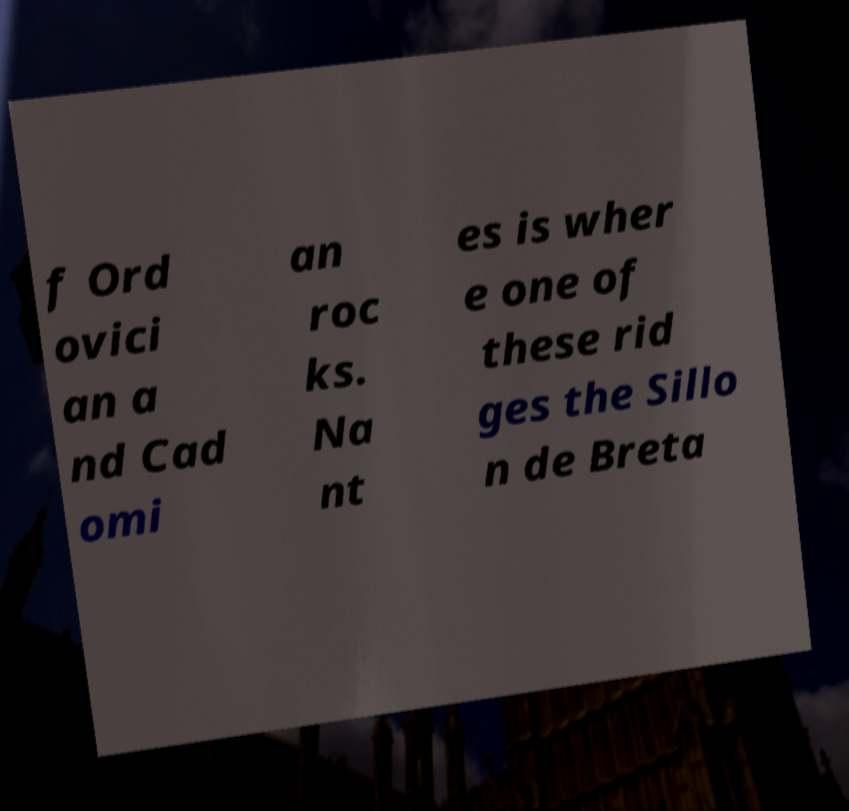Could you assist in decoding the text presented in this image and type it out clearly? f Ord ovici an a nd Cad omi an roc ks. Na nt es is wher e one of these rid ges the Sillo n de Breta 